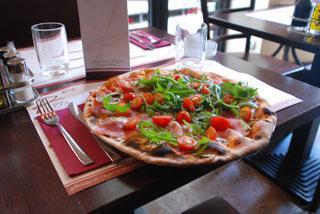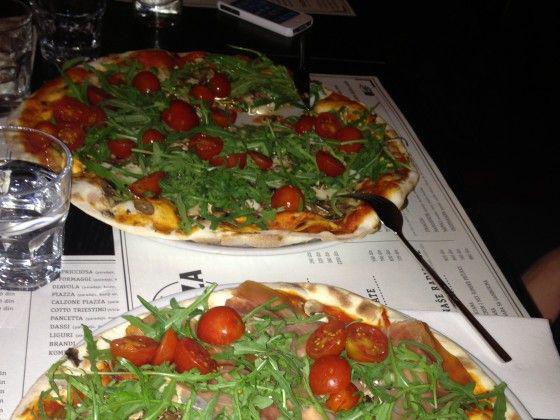The first image is the image on the left, the second image is the image on the right. Given the left and right images, does the statement "In one of the images, a very long pizza appears to have three sections, with different toppings in each of the sections." hold true? Answer yes or no. No. The first image is the image on the left, the second image is the image on the right. Considering the images on both sides, is "The left image features someone sitting at a wooden table behind a round pizza, with a glass of amber beverage next to the pizza." valid? Answer yes or no. No. 